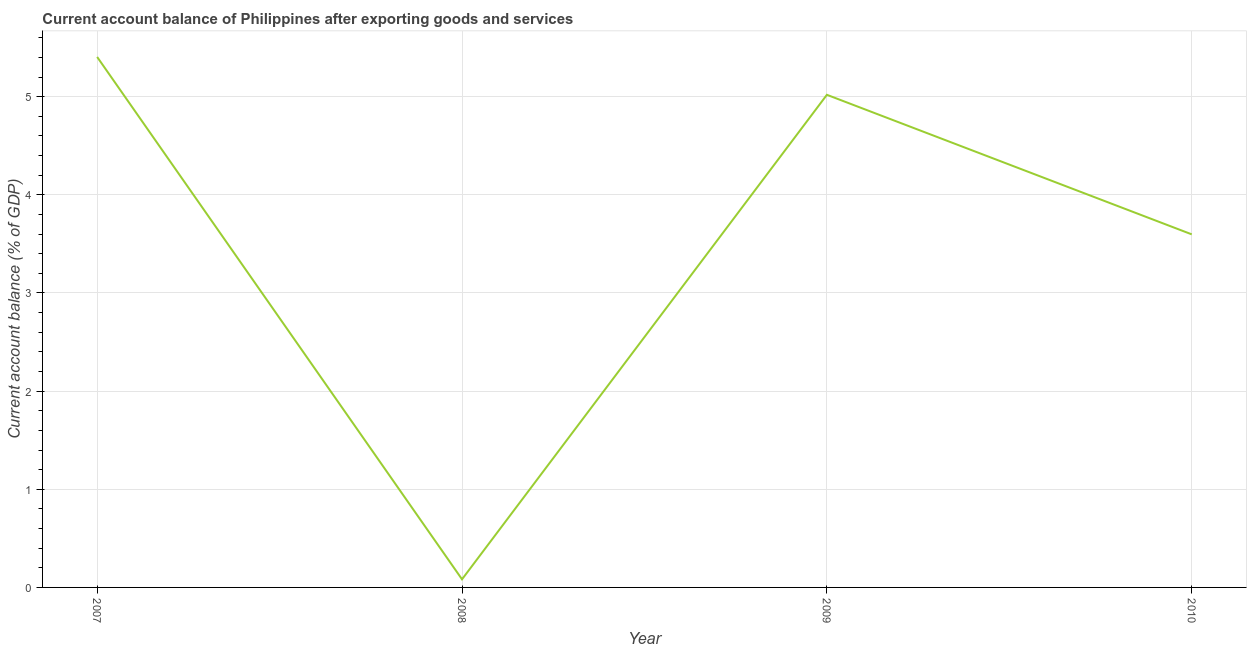What is the current account balance in 2007?
Give a very brief answer. 5.4. Across all years, what is the maximum current account balance?
Your answer should be compact. 5.4. Across all years, what is the minimum current account balance?
Your response must be concise. 0.08. In which year was the current account balance maximum?
Give a very brief answer. 2007. In which year was the current account balance minimum?
Provide a short and direct response. 2008. What is the sum of the current account balance?
Your answer should be very brief. 14.1. What is the difference between the current account balance in 2008 and 2009?
Provide a succinct answer. -4.94. What is the average current account balance per year?
Your response must be concise. 3.53. What is the median current account balance?
Provide a short and direct response. 4.31. Do a majority of the years between 2007 and 2008 (inclusive) have current account balance greater than 2.2 %?
Provide a succinct answer. No. What is the ratio of the current account balance in 2009 to that in 2010?
Your answer should be very brief. 1.4. Is the current account balance in 2007 less than that in 2010?
Give a very brief answer. No. What is the difference between the highest and the second highest current account balance?
Ensure brevity in your answer.  0.39. What is the difference between the highest and the lowest current account balance?
Keep it short and to the point. 5.32. In how many years, is the current account balance greater than the average current account balance taken over all years?
Make the answer very short. 3. Does the current account balance monotonically increase over the years?
Your answer should be very brief. No. How many lines are there?
Ensure brevity in your answer.  1. Are the values on the major ticks of Y-axis written in scientific E-notation?
Provide a succinct answer. No. Does the graph contain grids?
Offer a terse response. Yes. What is the title of the graph?
Your answer should be very brief. Current account balance of Philippines after exporting goods and services. What is the label or title of the Y-axis?
Keep it short and to the point. Current account balance (% of GDP). What is the Current account balance (% of GDP) of 2007?
Ensure brevity in your answer.  5.4. What is the Current account balance (% of GDP) of 2008?
Provide a succinct answer. 0.08. What is the Current account balance (% of GDP) of 2009?
Make the answer very short. 5.02. What is the Current account balance (% of GDP) of 2010?
Provide a succinct answer. 3.6. What is the difference between the Current account balance (% of GDP) in 2007 and 2008?
Offer a very short reply. 5.32. What is the difference between the Current account balance (% of GDP) in 2007 and 2009?
Keep it short and to the point. 0.39. What is the difference between the Current account balance (% of GDP) in 2007 and 2010?
Ensure brevity in your answer.  1.81. What is the difference between the Current account balance (% of GDP) in 2008 and 2009?
Ensure brevity in your answer.  -4.94. What is the difference between the Current account balance (% of GDP) in 2008 and 2010?
Give a very brief answer. -3.51. What is the difference between the Current account balance (% of GDP) in 2009 and 2010?
Offer a terse response. 1.42. What is the ratio of the Current account balance (% of GDP) in 2007 to that in 2008?
Your answer should be very brief. 65.37. What is the ratio of the Current account balance (% of GDP) in 2007 to that in 2009?
Ensure brevity in your answer.  1.08. What is the ratio of the Current account balance (% of GDP) in 2007 to that in 2010?
Your answer should be compact. 1.5. What is the ratio of the Current account balance (% of GDP) in 2008 to that in 2009?
Offer a very short reply. 0.02. What is the ratio of the Current account balance (% of GDP) in 2008 to that in 2010?
Make the answer very short. 0.02. What is the ratio of the Current account balance (% of GDP) in 2009 to that in 2010?
Give a very brief answer. 1.4. 